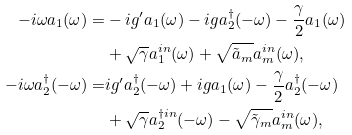<formula> <loc_0><loc_0><loc_500><loc_500>- i \omega a _ { 1 } ( \omega ) = & - i g ^ { \prime } a _ { 1 } ( \omega ) - i g a _ { 2 } ^ { \dagger } ( - \omega ) - \frac { \gamma } { 2 } a _ { 1 } ( \omega ) \\ & + \sqrt { \gamma } a _ { 1 } ^ { i n } ( \omega ) + \sqrt { \tilde { a } _ { m } } a _ { m } ^ { i n } ( \omega ) , \\ - i \omega a ^ { \dagger } _ { 2 } ( - \omega ) = & i g ^ { \prime } a _ { 2 } ^ { \dagger } ( - \omega ) + i g a _ { 1 } ( \omega ) - \frac { \gamma } { 2 } a _ { 2 } ^ { \dagger } ( - \omega ) \\ & + \sqrt { \gamma } a _ { 2 } ^ { \dagger i n } ( - \omega ) - \sqrt { \tilde { \gamma } _ { m } } a _ { m } ^ { i n } ( \omega ) ,</formula> 